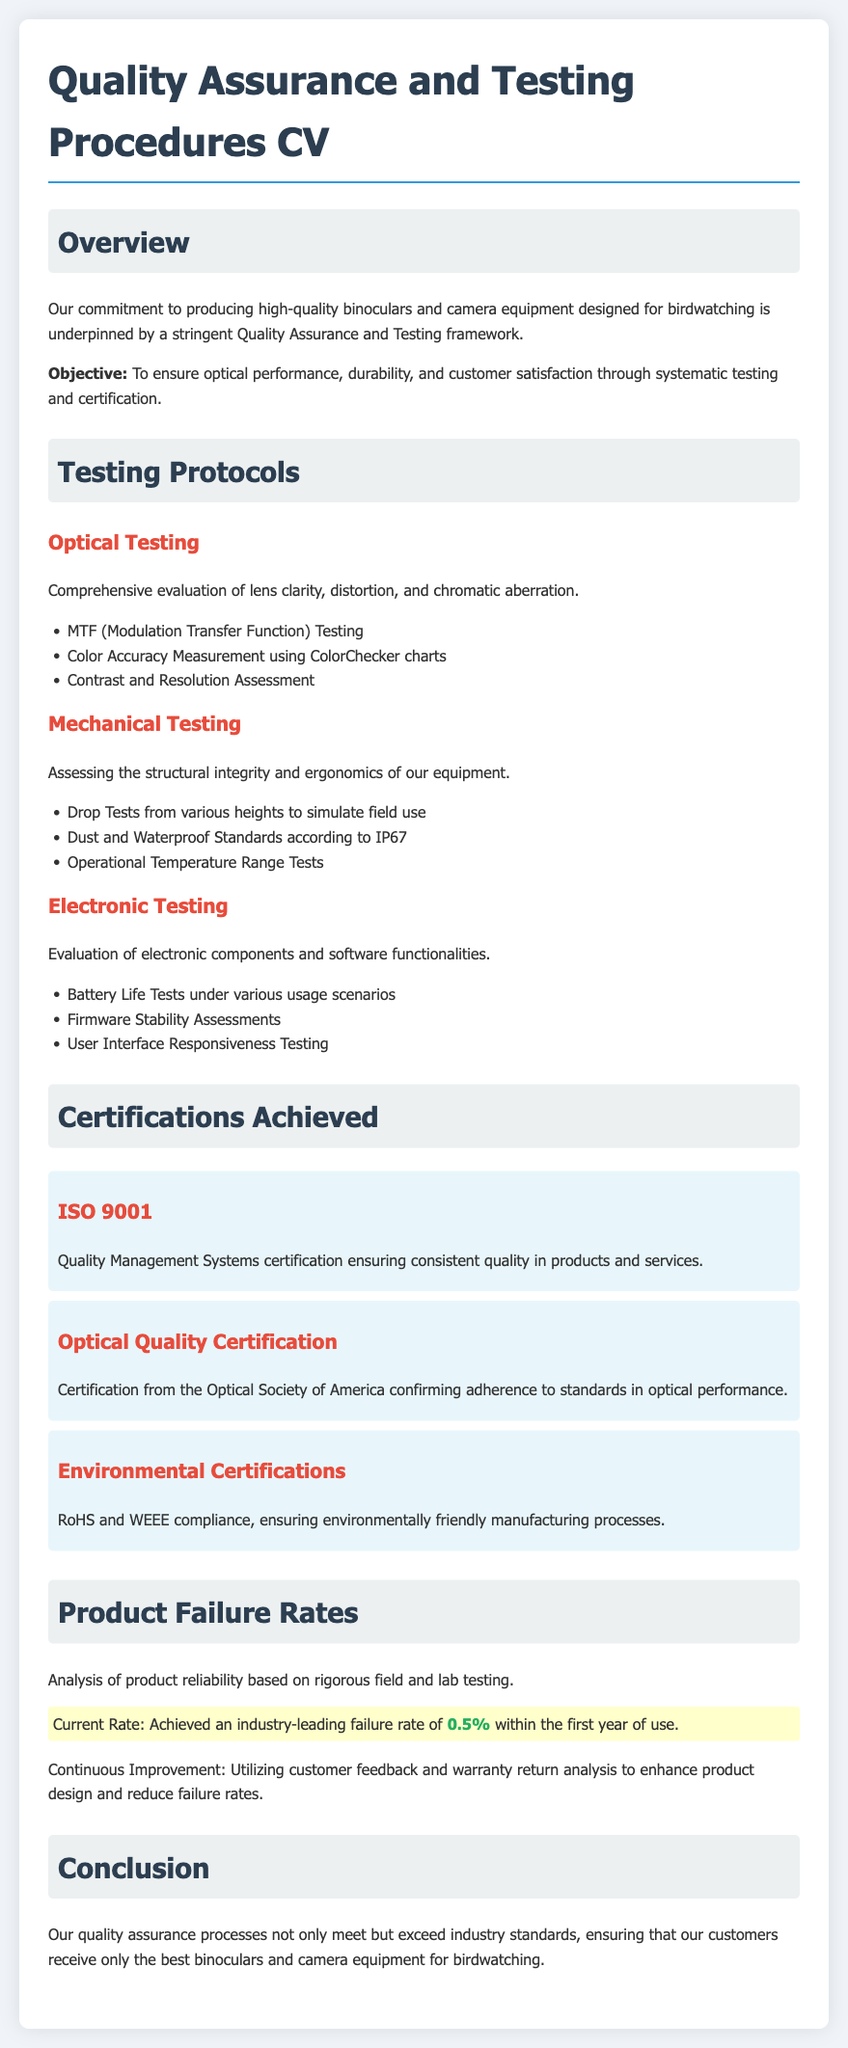what is the objective of the Quality Assurance and Testing framework? The objective is to ensure optical performance, durability, and customer satisfaction through systematic testing and certification.
Answer: To ensure optical performance, durability, and customer satisfaction what certification ensures consistent quality in products and services? The document mentions ISO 9001 as the certification ensuring consistent quality.
Answer: ISO 9001 what is the current product failure rate? The current rate of product failure, according to the document, is specified as 0.5%.
Answer: 0.5% which testing evaluates lens clarity and distortion? Optical Testing is the testing that evaluates lens clarity and distortion.
Answer: Optical Testing what environmental certifications are mentioned? The document specifies RoHS and WEEE compliance as the environmental certifications achieved.
Answer: RoHS and WEEE how do they ensure continuous improvement? Continuous improvement is achieved by utilizing customer feedback and warranty return analysis.
Answer: Customer feedback and warranty return analysis what specific test simulates field use? Drop Tests from various heights are conducted to simulate field use.
Answer: Drop Tests which organization provides Optical Quality Certification? The Optical Society of America provides the Optical Quality Certification mentioned in the document.
Answer: Optical Society of America 